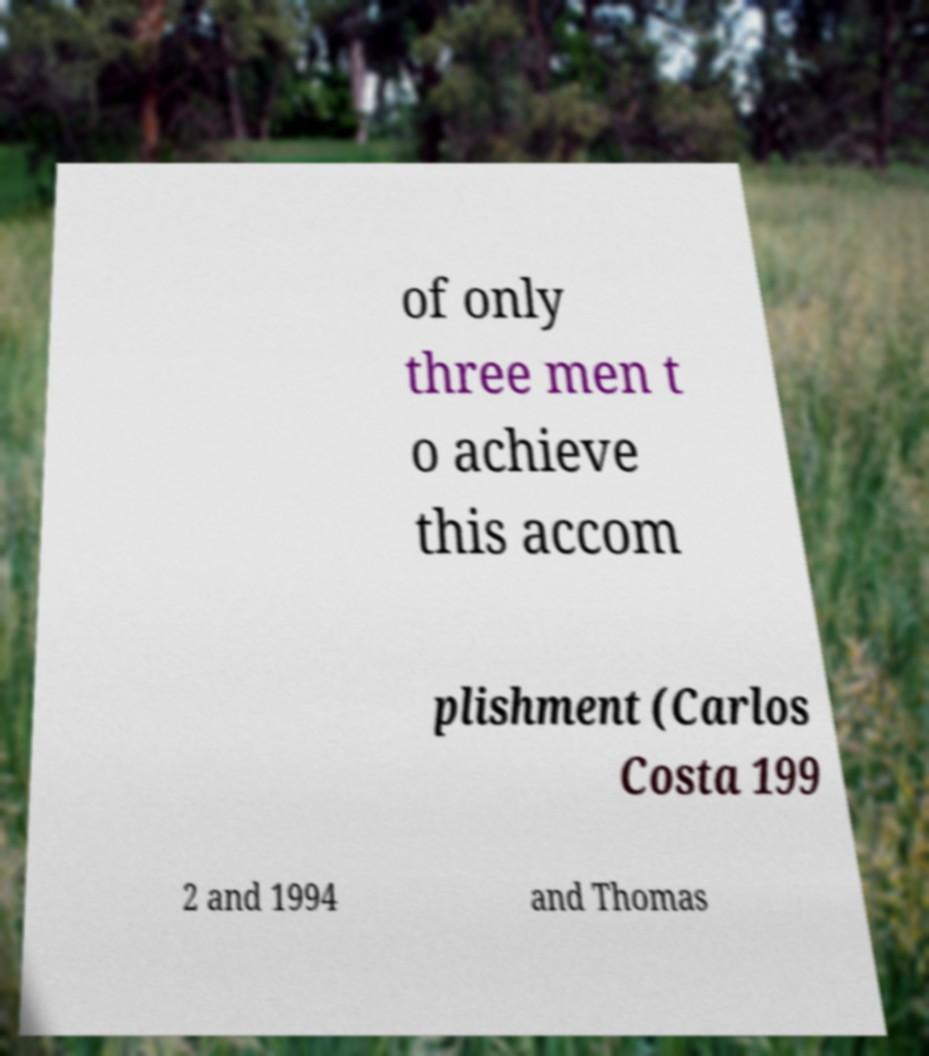Please read and relay the text visible in this image. What does it say? of only three men t o achieve this accom plishment (Carlos Costa 199 2 and 1994 and Thomas 